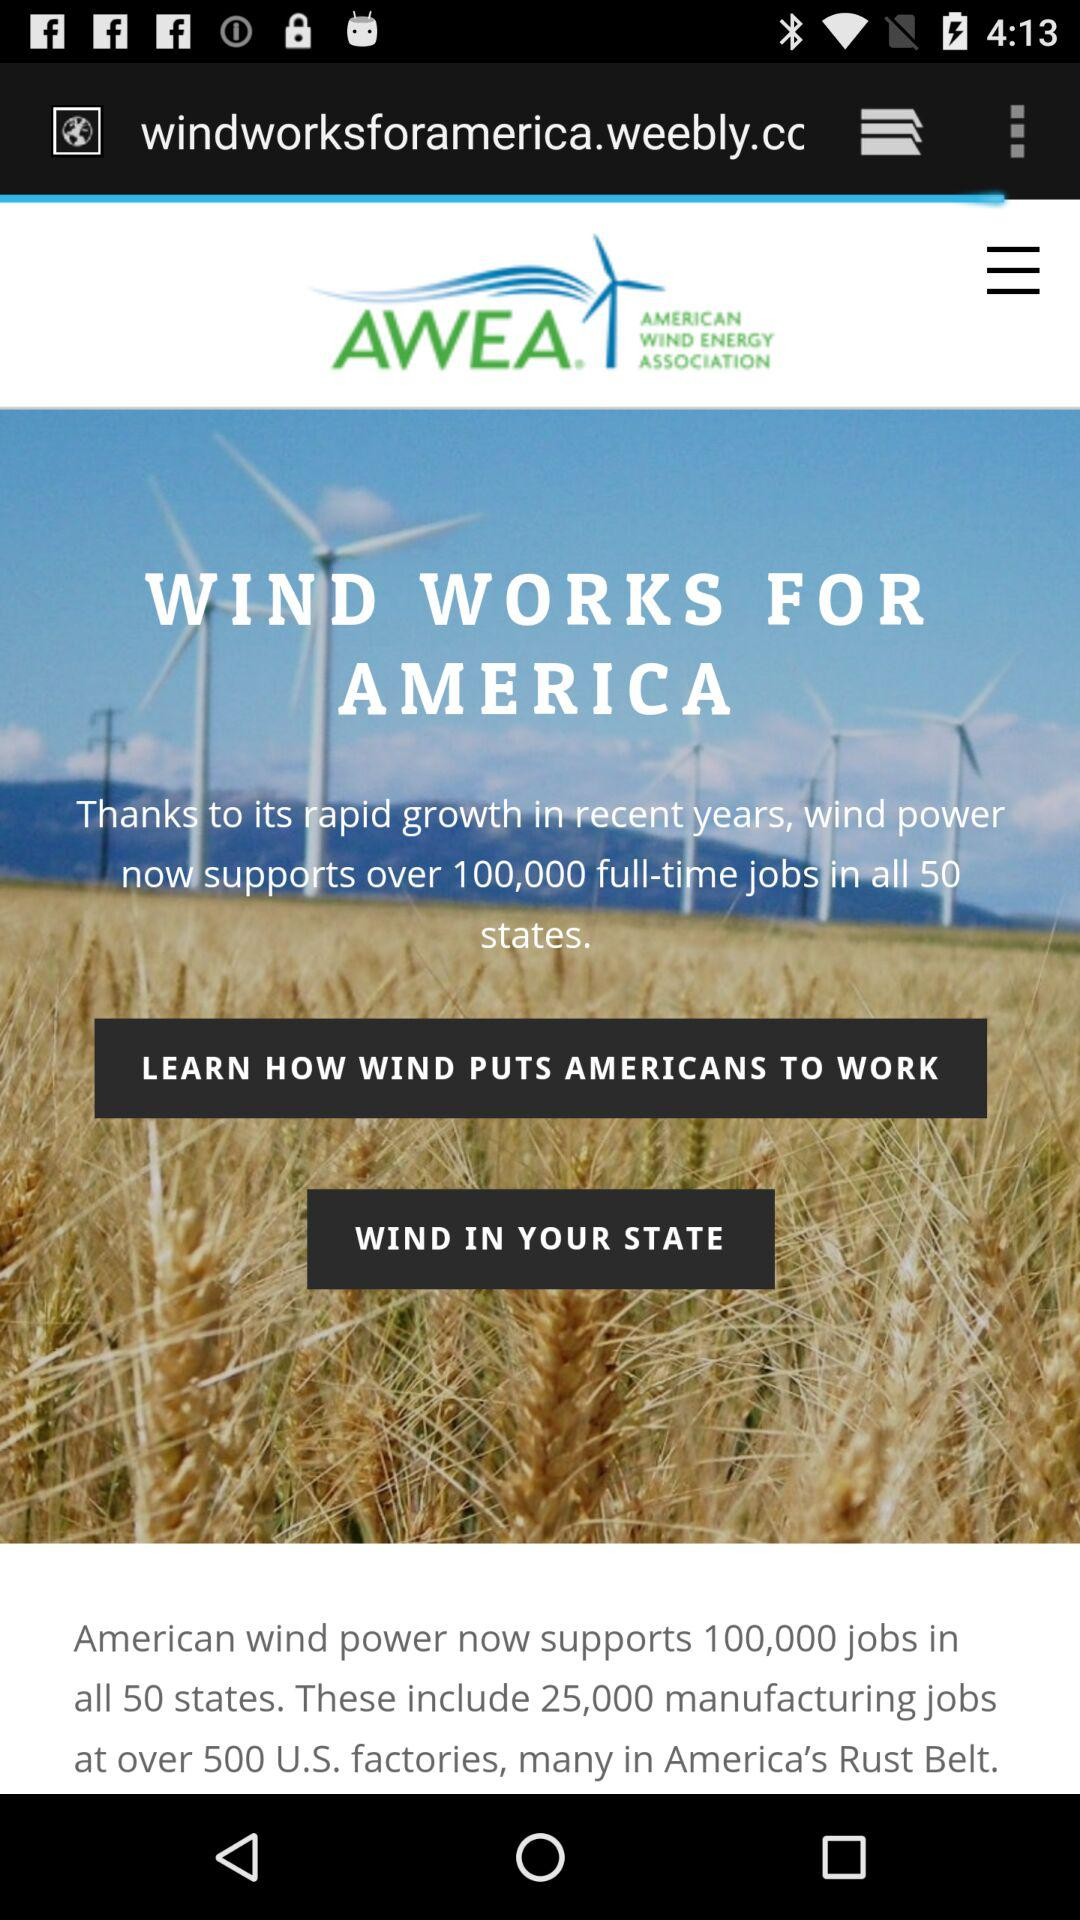How many manufacturing jobs does American wind power include? There are 25,000 manufacturing jobs. 